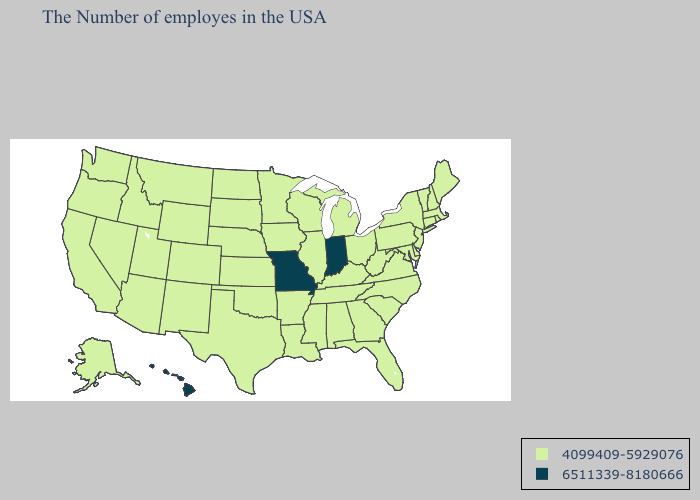Name the states that have a value in the range 6511339-8180666?
Keep it brief. Indiana, Missouri, Hawaii. Does Nebraska have the highest value in the USA?
Concise answer only. No. Name the states that have a value in the range 6511339-8180666?
Short answer required. Indiana, Missouri, Hawaii. What is the lowest value in the MidWest?
Keep it brief. 4099409-5929076. Name the states that have a value in the range 4099409-5929076?
Short answer required. Maine, Massachusetts, Rhode Island, New Hampshire, Vermont, Connecticut, New York, New Jersey, Delaware, Maryland, Pennsylvania, Virginia, North Carolina, South Carolina, West Virginia, Ohio, Florida, Georgia, Michigan, Kentucky, Alabama, Tennessee, Wisconsin, Illinois, Mississippi, Louisiana, Arkansas, Minnesota, Iowa, Kansas, Nebraska, Oklahoma, Texas, South Dakota, North Dakota, Wyoming, Colorado, New Mexico, Utah, Montana, Arizona, Idaho, Nevada, California, Washington, Oregon, Alaska. Does Hawaii have the lowest value in the USA?
Write a very short answer. No. Name the states that have a value in the range 6511339-8180666?
Answer briefly. Indiana, Missouri, Hawaii. Name the states that have a value in the range 4099409-5929076?
Be succinct. Maine, Massachusetts, Rhode Island, New Hampshire, Vermont, Connecticut, New York, New Jersey, Delaware, Maryland, Pennsylvania, Virginia, North Carolina, South Carolina, West Virginia, Ohio, Florida, Georgia, Michigan, Kentucky, Alabama, Tennessee, Wisconsin, Illinois, Mississippi, Louisiana, Arkansas, Minnesota, Iowa, Kansas, Nebraska, Oklahoma, Texas, South Dakota, North Dakota, Wyoming, Colorado, New Mexico, Utah, Montana, Arizona, Idaho, Nevada, California, Washington, Oregon, Alaska. Name the states that have a value in the range 4099409-5929076?
Keep it brief. Maine, Massachusetts, Rhode Island, New Hampshire, Vermont, Connecticut, New York, New Jersey, Delaware, Maryland, Pennsylvania, Virginia, North Carolina, South Carolina, West Virginia, Ohio, Florida, Georgia, Michigan, Kentucky, Alabama, Tennessee, Wisconsin, Illinois, Mississippi, Louisiana, Arkansas, Minnesota, Iowa, Kansas, Nebraska, Oklahoma, Texas, South Dakota, North Dakota, Wyoming, Colorado, New Mexico, Utah, Montana, Arizona, Idaho, Nevada, California, Washington, Oregon, Alaska. Does the first symbol in the legend represent the smallest category?
Be succinct. Yes. What is the lowest value in the USA?
Write a very short answer. 4099409-5929076. What is the lowest value in states that border Illinois?
Keep it brief. 4099409-5929076. Which states have the highest value in the USA?
Short answer required. Indiana, Missouri, Hawaii. Does the map have missing data?
Be succinct. No. What is the value of Alabama?
Short answer required. 4099409-5929076. 